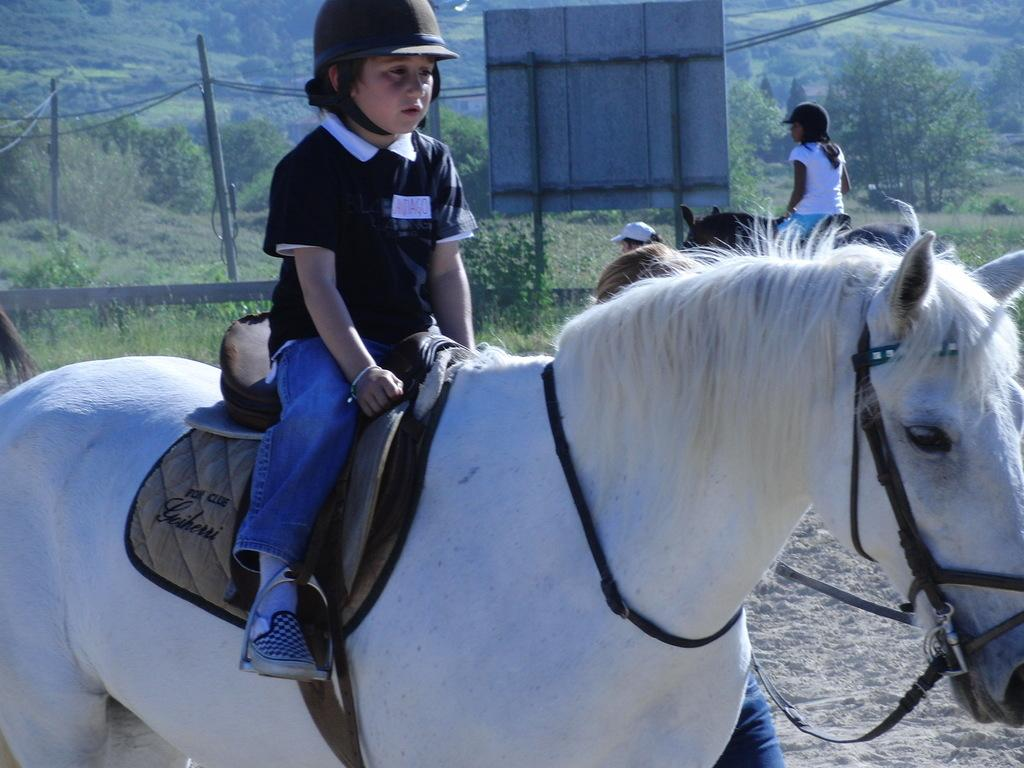How many horses are in the image? There are two horses in the image. What is the kid doing in the image? A kid is sitting on the first horse. What color is the first horse? The first horse is white in color. What can be seen in the background of the image? There are trees, a board, and wires in the background of the image. Where is the grandfather's bedroom located in the image? There is no mention of a grandfather or a bedroom in the image. The image features two horses, a kid, and elements in the background. 